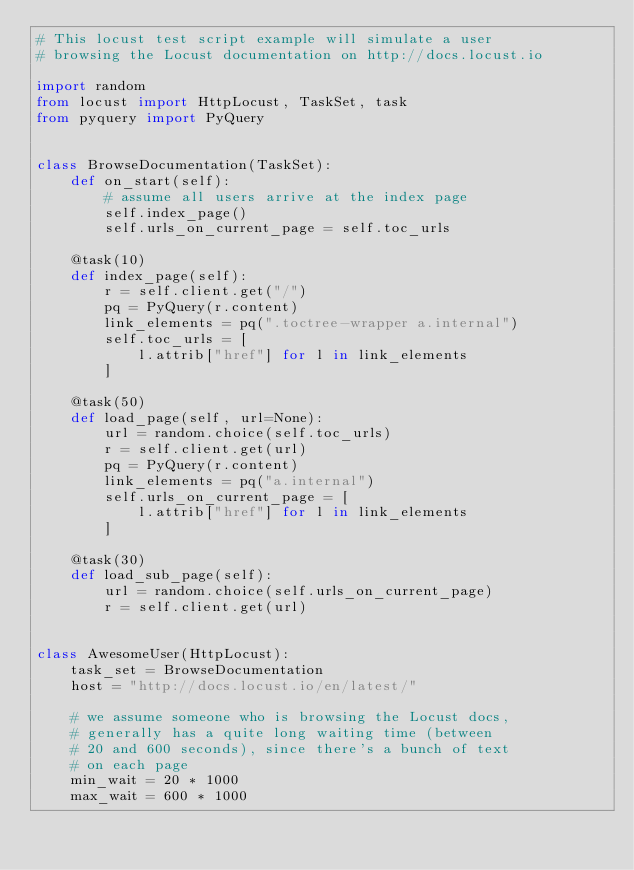<code> <loc_0><loc_0><loc_500><loc_500><_Python_># This locust test script example will simulate a user
# browsing the Locust documentation on http://docs.locust.io

import random
from locust import HttpLocust, TaskSet, task
from pyquery import PyQuery


class BrowseDocumentation(TaskSet):
    def on_start(self):
        # assume all users arrive at the index page
        self.index_page()
        self.urls_on_current_page = self.toc_urls

    @task(10)
    def index_page(self):
        r = self.client.get("/")
        pq = PyQuery(r.content)
        link_elements = pq(".toctree-wrapper a.internal")
        self.toc_urls = [
            l.attrib["href"] for l in link_elements
        ]

    @task(50)
    def load_page(self, url=None):
        url = random.choice(self.toc_urls)
        r = self.client.get(url)
        pq = PyQuery(r.content)
        link_elements = pq("a.internal")
        self.urls_on_current_page = [
            l.attrib["href"] for l in link_elements
        ]

    @task(30)
    def load_sub_page(self):
        url = random.choice(self.urls_on_current_page)
        r = self.client.get(url)


class AwesomeUser(HttpLocust):
    task_set = BrowseDocumentation
    host = "http://docs.locust.io/en/latest/"

    # we assume someone who is browsing the Locust docs,
    # generally has a quite long waiting time (between
    # 20 and 600 seconds), since there's a bunch of text
    # on each page
    min_wait = 20 * 1000
    max_wait = 600 * 1000</code> 